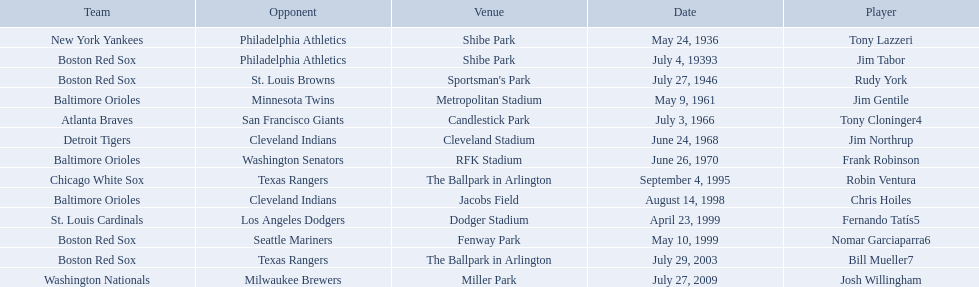Who were all of the players? Tony Lazzeri, Jim Tabor, Rudy York, Jim Gentile, Tony Cloninger4, Jim Northrup, Frank Robinson, Robin Ventura, Chris Hoiles, Fernando Tatís5, Nomar Garciaparra6, Bill Mueller7, Josh Willingham. What year was there a player for the yankees? May 24, 1936. What was the name of that 1936 yankees player? Tony Lazzeri. 